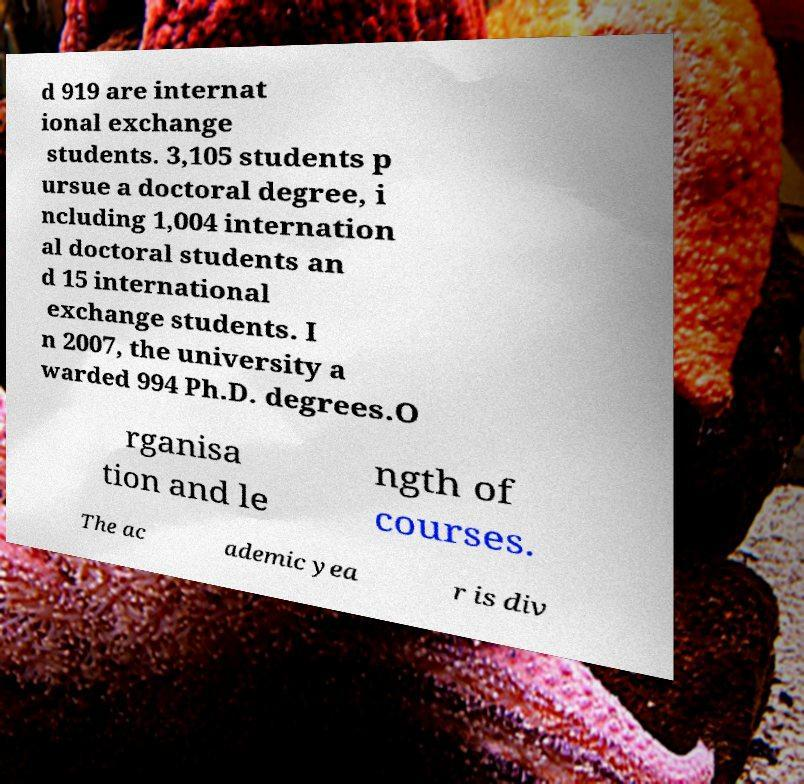Can you read and provide the text displayed in the image?This photo seems to have some interesting text. Can you extract and type it out for me? d 919 are internat ional exchange students. 3,105 students p ursue a doctoral degree, i ncluding 1,004 internation al doctoral students an d 15 international exchange students. I n 2007, the university a warded 994 Ph.D. degrees.O rganisa tion and le ngth of courses. The ac ademic yea r is div 